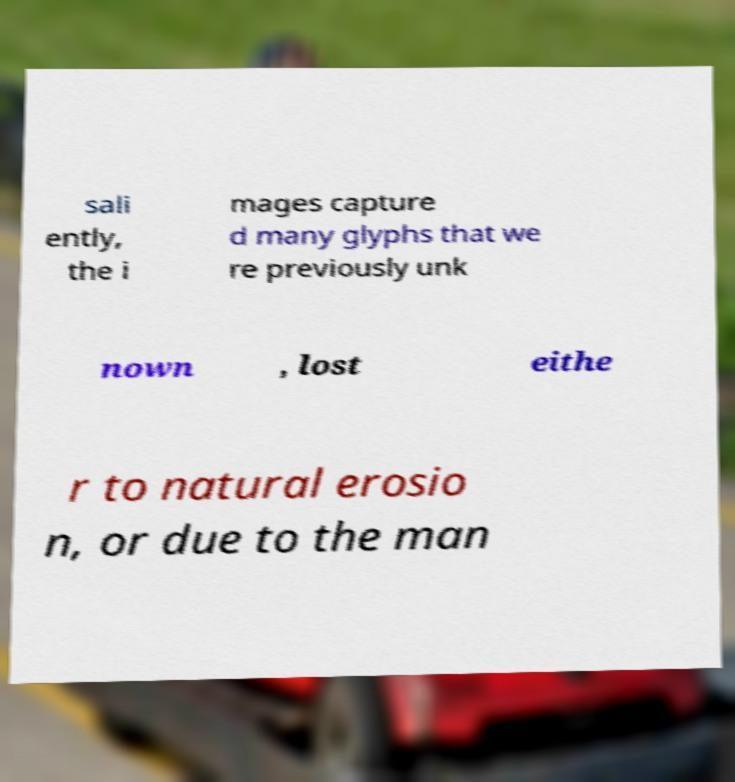Please identify and transcribe the text found in this image. sali ently, the i mages capture d many glyphs that we re previously unk nown , lost eithe r to natural erosio n, or due to the man 